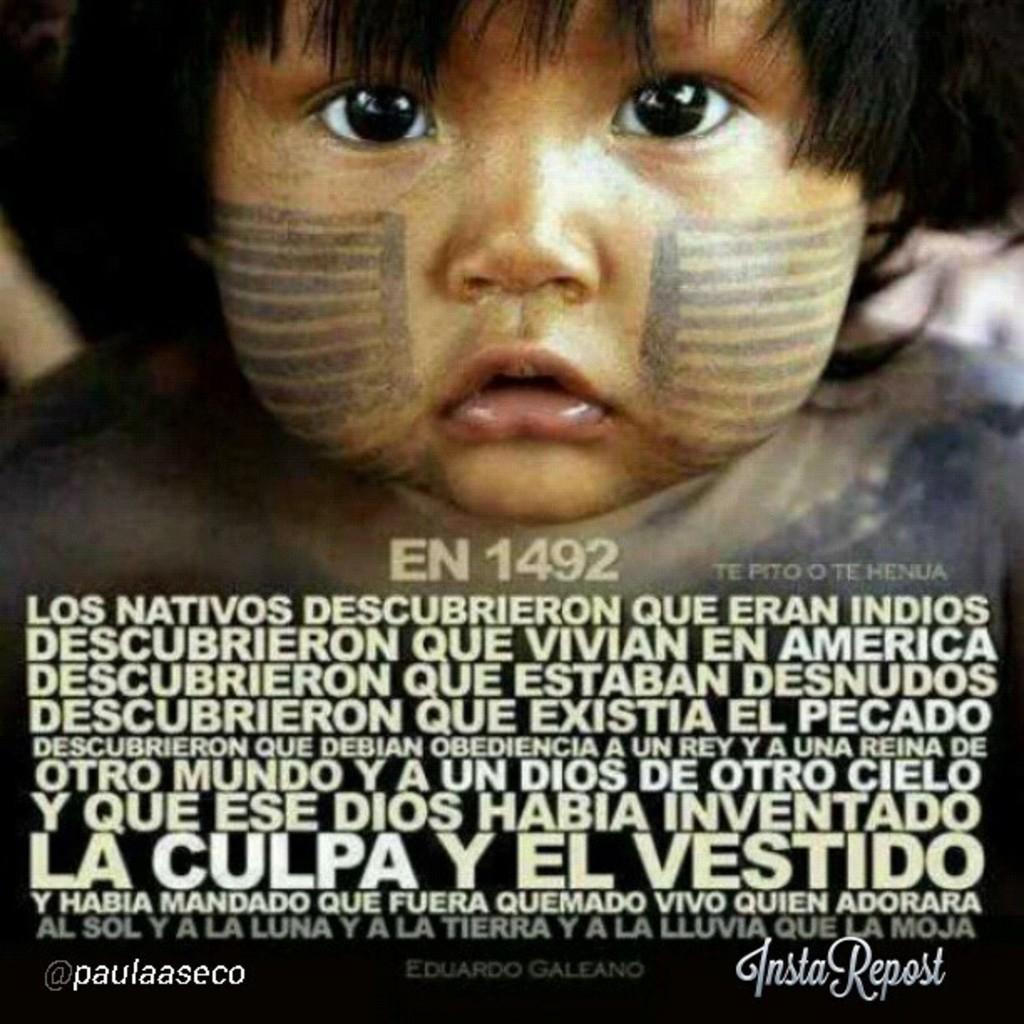What is the main object in the image? There is a magazine in the image. What can be seen on the cover of the magazine? The magazine has an image of a small baby's face. Is there any text or information related to the baby's face image? Yes, there is information below the baby's face image. Can you tell me how many strangers are shown playing basketball in the image? There are no strangers or basketball players present in the image; it features a magazine with a baby's face on the cover. What emotion does the baby's face convey in the image? The baby's face image is not associated with any specific emotion in the image, as it is a still photograph. 